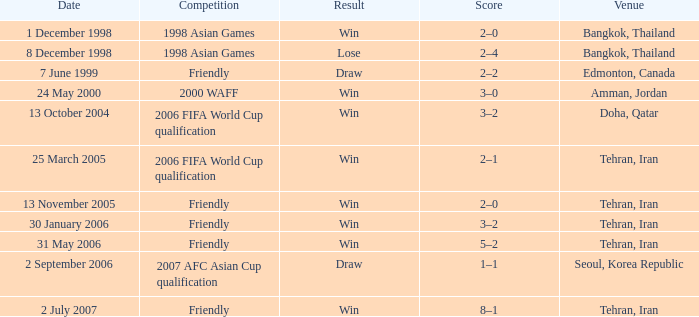Where was the friendly competition on 7 June 1999 played? Edmonton, Canada. 